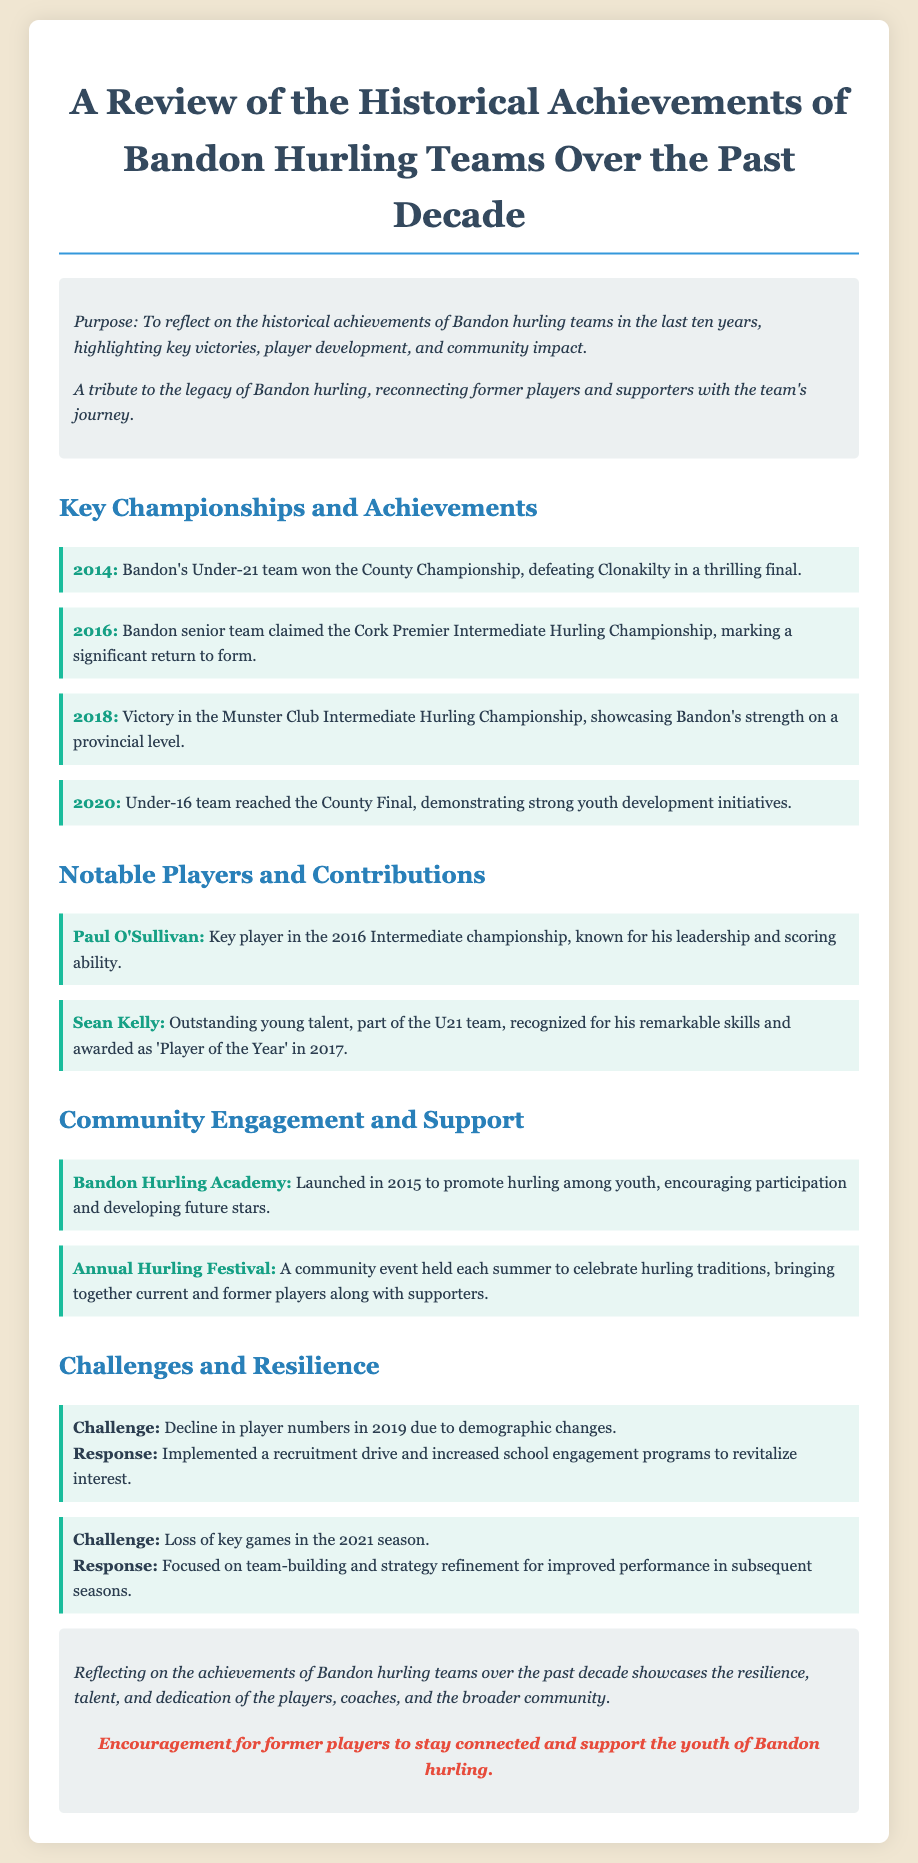What championship did Bandon's Under-21 team win in 2014? The document states that Bandon's Under-21 team won the County Championship, which is a specific achievement listed in 2014.
Answer: County Championship Which team won the Cork Premier Intermediate Hurling Championship in 2016? According to the document, the Bandon senior team claimed the Cork Premier Intermediate Hurling Championship in 2016.
Answer: Bandon senior team What year did Bandon's Under-16 team reach the County Final? The document specifies that the Under-16 team reached the County Final in 2020, thus directly answering the question based on the achievements listed.
Answer: 2020 Who was recognized as 'Player of the Year' in 2017? The document mentions Sean Kelly, who was awarded 'Player of the Year' in 2017, as part of the notable players and contributions section.
Answer: Sean Kelly What event was launched in 2015 to promote youth involvement in hurling? The document notes the Bandon Hurling Academy was initiated in 2015 aimed at encouraging youth participation in hurling.
Answer: Bandon Hurling Academy What was the response to the decline in player numbers in 2019? The document describes that a recruitment drive and increased school engagement programs were implemented as a response to the decline in player numbers.
Answer: Recruitment drive What type of event is held each summer in Bandon? The document refers to the Annual Hurling Festival, which is a community event celebrating hurling traditions, thereby answering the question about the type of event.
Answer: Annual Hurling Festival What significant victory was achieved in 2018? According to the document, Bandon won the Munster Club Intermediate Hurling Championship in 2018, which highlights a key achievement.
Answer: Munster Club Intermediate Hurling Championship 